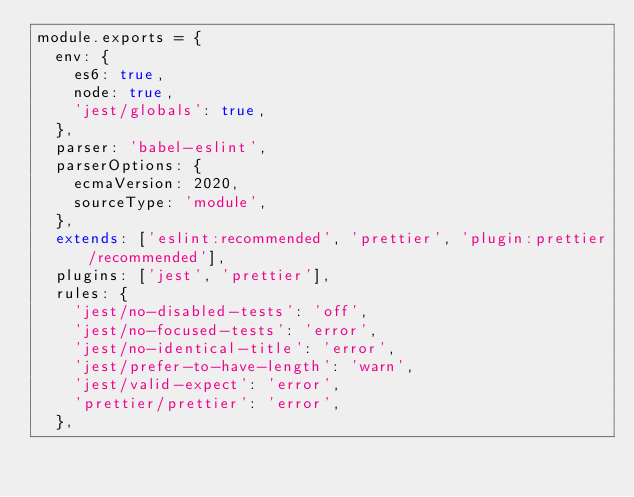<code> <loc_0><loc_0><loc_500><loc_500><_JavaScript_>module.exports = {
  env: {
    es6: true,
    node: true,
    'jest/globals': true,
  },
  parser: 'babel-eslint',
  parserOptions: {
    ecmaVersion: 2020,
    sourceType: 'module',
  },
  extends: ['eslint:recommended', 'prettier', 'plugin:prettier/recommended'],
  plugins: ['jest', 'prettier'],
  rules: {
    'jest/no-disabled-tests': 'off',
    'jest/no-focused-tests': 'error',
    'jest/no-identical-title': 'error',
    'jest/prefer-to-have-length': 'warn',
    'jest/valid-expect': 'error',
    'prettier/prettier': 'error',
  },</code> 